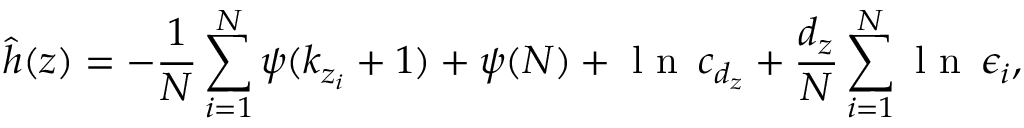<formula> <loc_0><loc_0><loc_500><loc_500>\widehat { h } ( z ) = - \frac { 1 } { N } \sum _ { i = 1 } ^ { N } \psi ( k _ { z _ { i } } + 1 ) + \psi ( N ) + l n \, c _ { d _ { z } } + \frac { d _ { z } } { N } \sum _ { i = 1 } ^ { N } l n \, \epsilon _ { i } ,</formula> 